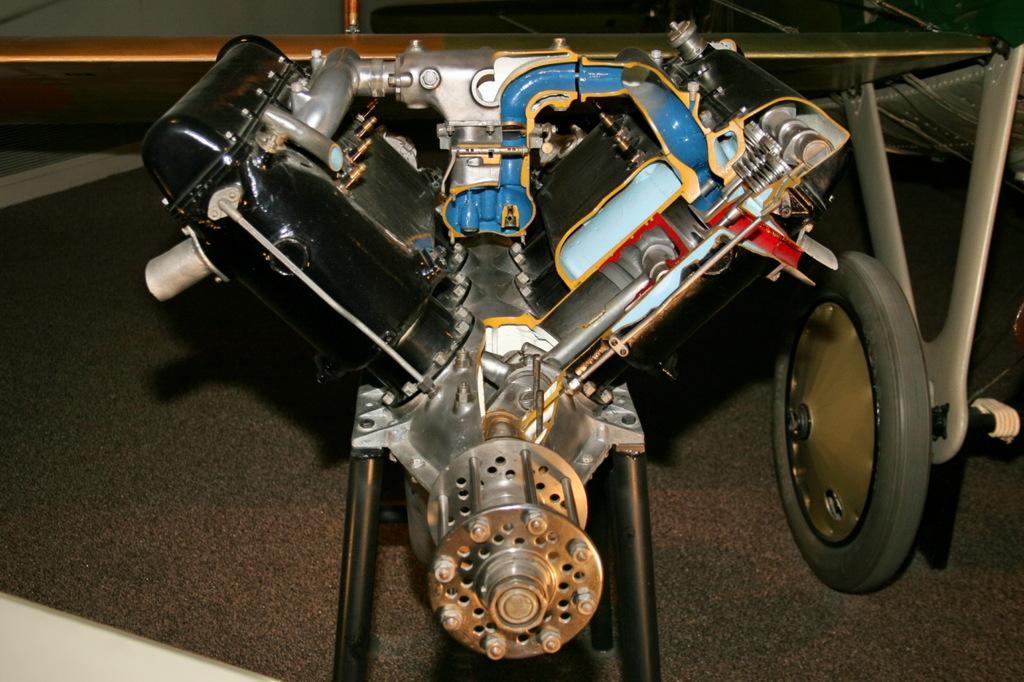Please provide a concise description of this image. In this image we can see a motor machine. 